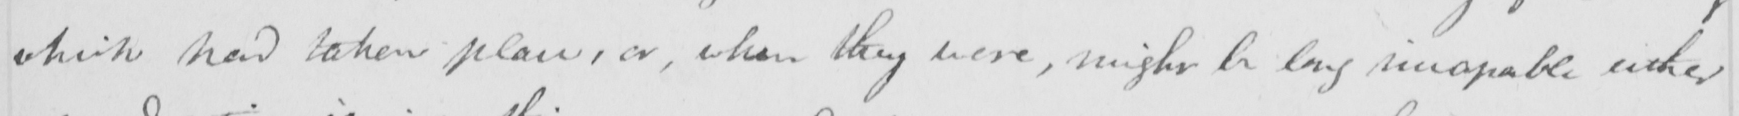Transcribe the text shown in this historical manuscript line. which had taken place , or , when they were , might be long incapable either 